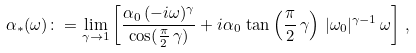Convert formula to latex. <formula><loc_0><loc_0><loc_500><loc_500>\alpha _ { * } ( \omega ) \colon = \lim _ { \gamma \to 1 } \left [ \frac { \alpha _ { 0 } \, ( - i \omega ) ^ { \gamma } } { \cos ( \frac { \pi } { 2 } \, \gamma ) } + i \alpha _ { 0 } \, \tan \left ( \frac { \pi } { 2 } \, \gamma \right ) \, | \omega _ { 0 } | ^ { \gamma - 1 } \, \omega \right ] \, ,</formula> 